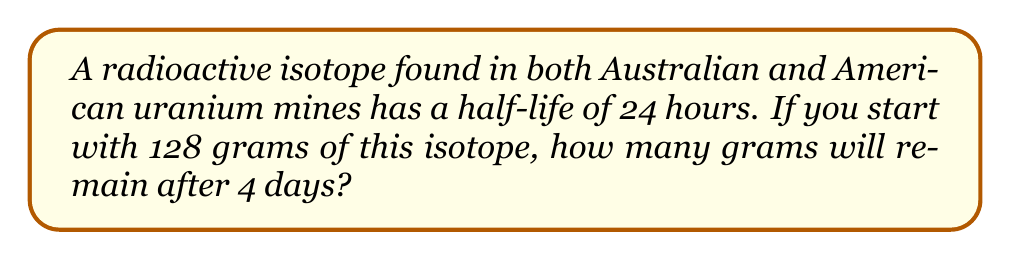Provide a solution to this math problem. Let's approach this step-by-step:

1) First, we need to determine how many half-lives have passed in 4 days.
   4 days = 96 hours
   Number of half-lives = 96 hours ÷ 24 hours = 4 half-lives

2) The exponential decay formula is:
   $A(t) = A_0 \cdot (\frac{1}{2})^n$
   Where:
   $A(t)$ is the amount remaining after time $t$
   $A_0$ is the initial amount
   $n$ is the number of half-lives

3) Plugging in our values:
   $A(t) = 128 \cdot (\frac{1}{2})^4$

4) Let's calculate this:
   $A(t) = 128 \cdot \frac{1}{16}$
   $A(t) = 8$

Therefore, after 4 days, 8 grams of the radioactive isotope will remain.
Answer: 8 grams 